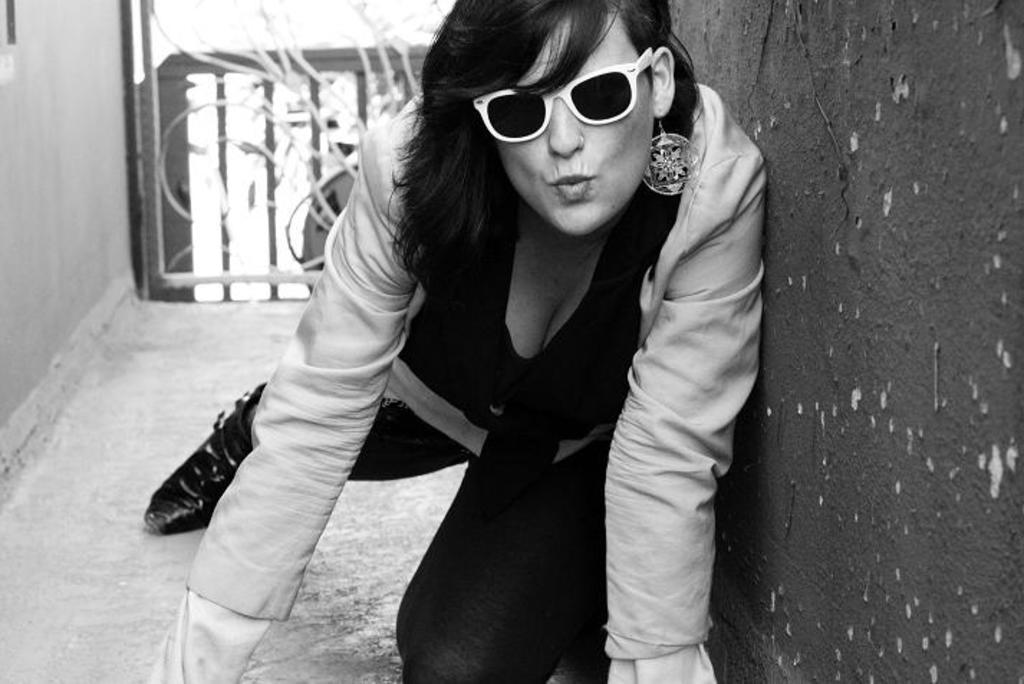Who is the main subject in the image? There is a person in the center of the image. What accessory is the person wearing? The person is wearing glasses. What can be seen on the right side of the image? There is a wall on the right side of the image. What is visible in the background of the image? There are objects visible in the background of the image. How many drawers are visible in the image? There are no drawers present in the image. What type of boats can be seen in the background of the image? There are no boats visible in the image; only objects in the background are mentioned. 